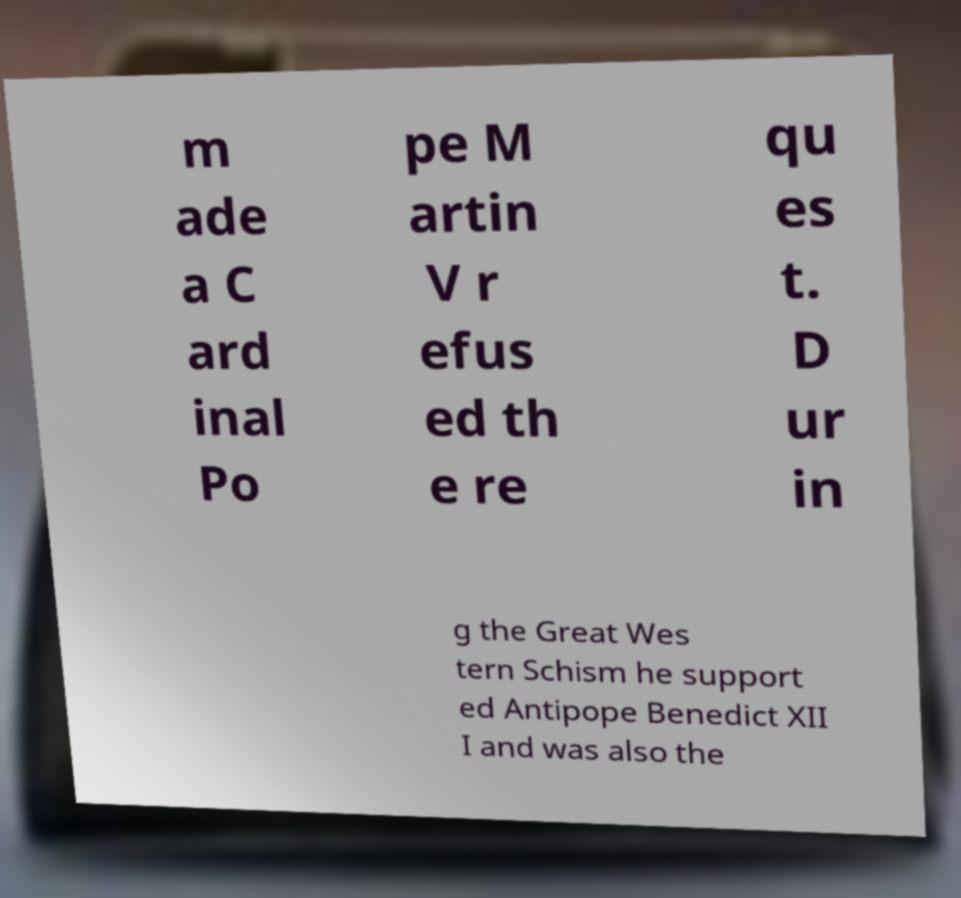What messages or text are displayed in this image? I need them in a readable, typed format. m ade a C ard inal Po pe M artin V r efus ed th e re qu es t. D ur in g the Great Wes tern Schism he support ed Antipope Benedict XII I and was also the 